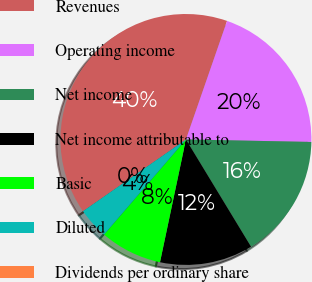Convert chart to OTSL. <chart><loc_0><loc_0><loc_500><loc_500><pie_chart><fcel>Revenues<fcel>Operating income<fcel>Net income<fcel>Net income attributable to<fcel>Basic<fcel>Diluted<fcel>Dividends per ordinary share<nl><fcel>40.0%<fcel>20.0%<fcel>16.0%<fcel>12.0%<fcel>8.0%<fcel>4.0%<fcel>0.0%<nl></chart> 